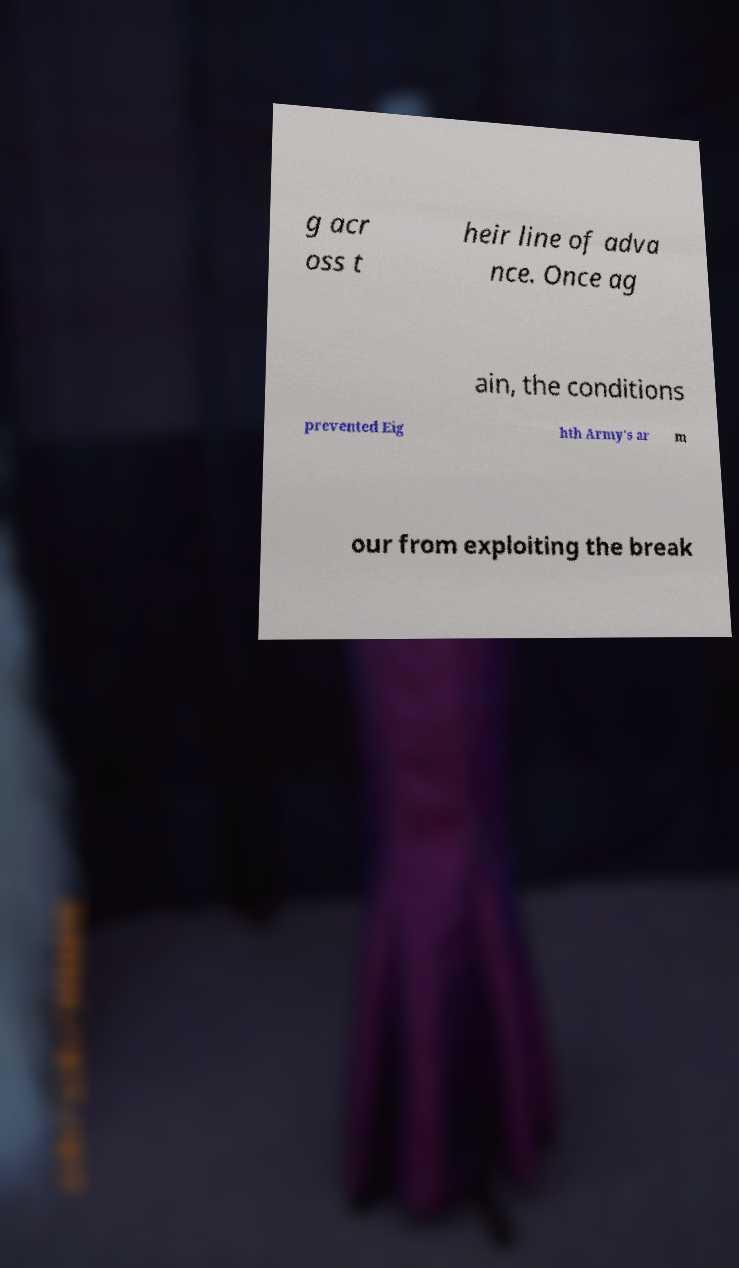Please identify and transcribe the text found in this image. g acr oss t heir line of adva nce. Once ag ain, the conditions prevented Eig hth Army's ar m our from exploiting the break 